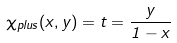<formula> <loc_0><loc_0><loc_500><loc_500>\chi _ { p l u s } ( x , y ) = t = { \frac { y } { 1 - x } }</formula> 